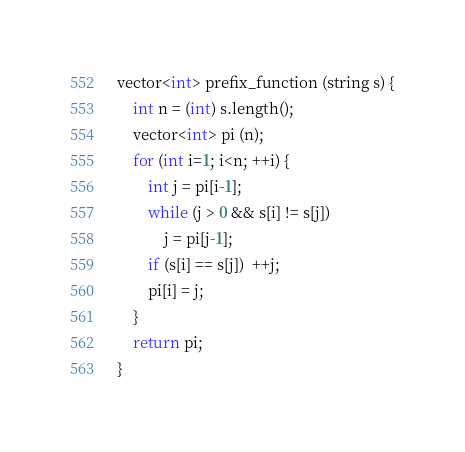Convert code to text. <code><loc_0><loc_0><loc_500><loc_500><_C++_>vector<int> prefix_function (string s) {
	int n = (int) s.length();
	vector<int> pi (n);
	for (int i=1; i<n; ++i) {
		int j = pi[i-1];
		while (j > 0 && s[i] != s[j])
			j = pi[j-1];
		if (s[i] == s[j])  ++j;
		pi[i] = j;
	}
	return pi;
}</code> 